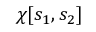<formula> <loc_0><loc_0><loc_500><loc_500>\chi [ s _ { 1 } , s _ { 2 } ]</formula> 